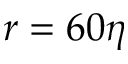Convert formula to latex. <formula><loc_0><loc_0><loc_500><loc_500>r = 6 0 \eta</formula> 